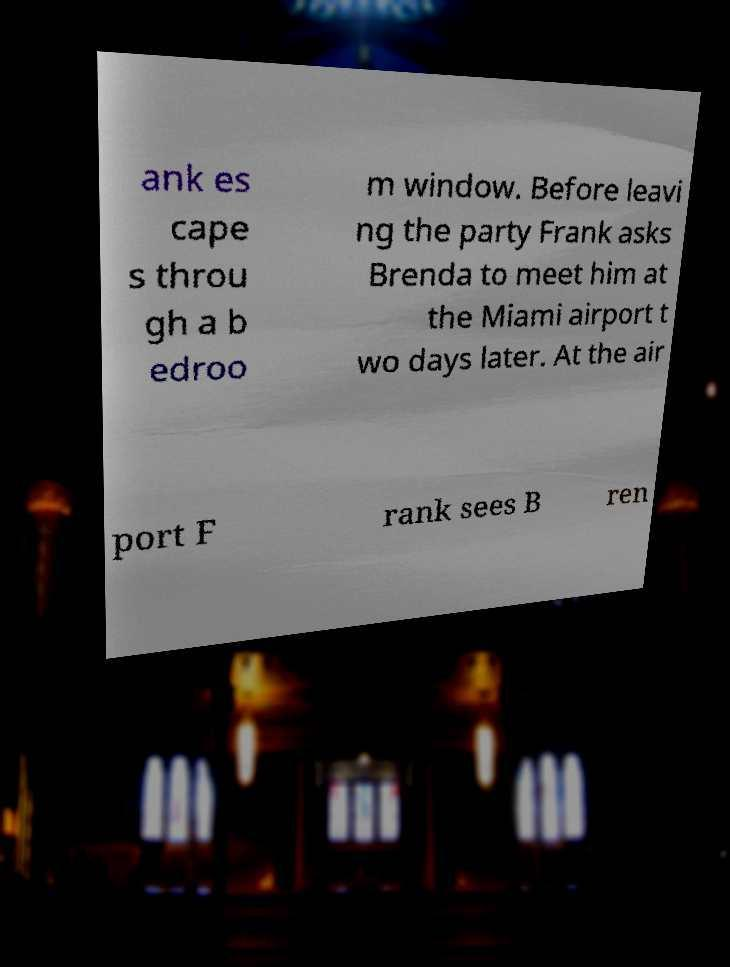Could you assist in decoding the text presented in this image and type it out clearly? ank es cape s throu gh a b edroo m window. Before leavi ng the party Frank asks Brenda to meet him at the Miami airport t wo days later. At the air port F rank sees B ren 